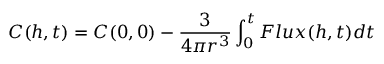Convert formula to latex. <formula><loc_0><loc_0><loc_500><loc_500>C ( h , t ) = C ( 0 , 0 ) - \frac { 3 } { 4 \pi r ^ { 3 } } \int _ { 0 } ^ { t } F l u x ( h , t ) d t</formula> 